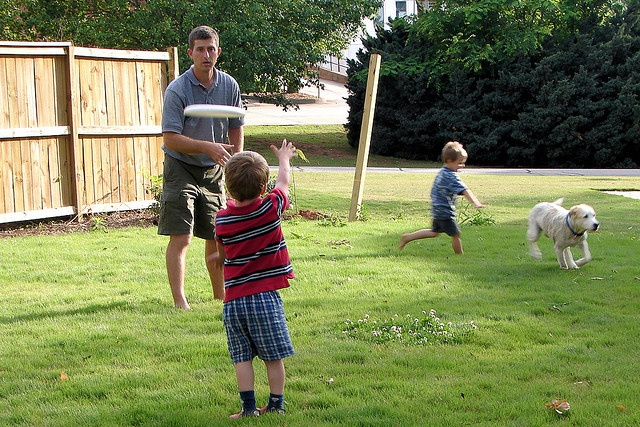Describe the objects in this image and their specific colors. I can see people in darkgreen, black, maroon, gray, and navy tones, people in darkgreen, black, gray, maroon, and brown tones, dog in darkgreen, darkgray, gray, and lightgray tones, people in darkgreen, black, gray, olive, and ivory tones, and frisbee in darkgreen, white, darkgray, and gray tones in this image. 